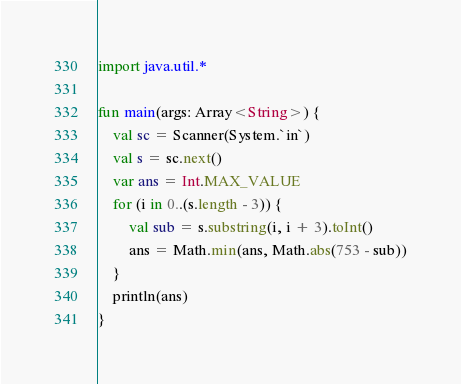Convert code to text. <code><loc_0><loc_0><loc_500><loc_500><_Kotlin_>import java.util.*

fun main(args: Array<String>) {
    val sc = Scanner(System.`in`)
    val s = sc.next()
    var ans = Int.MAX_VALUE
    for (i in 0..(s.length - 3)) {
        val sub = s.substring(i, i + 3).toInt()
        ans = Math.min(ans, Math.abs(753 - sub))
    }
    println(ans)
}</code> 